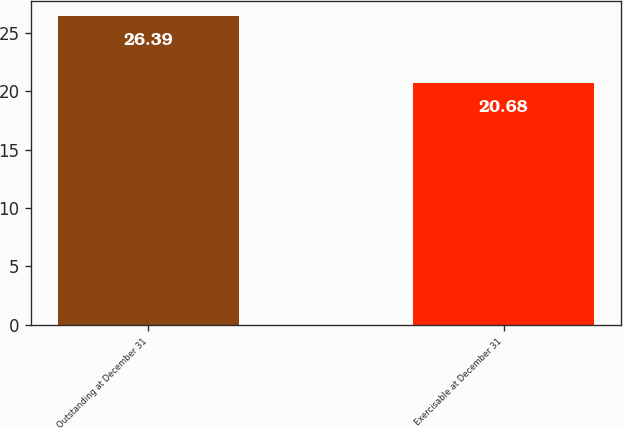<chart> <loc_0><loc_0><loc_500><loc_500><bar_chart><fcel>Outstanding at December 31<fcel>Exercisable at December 31<nl><fcel>26.39<fcel>20.68<nl></chart> 